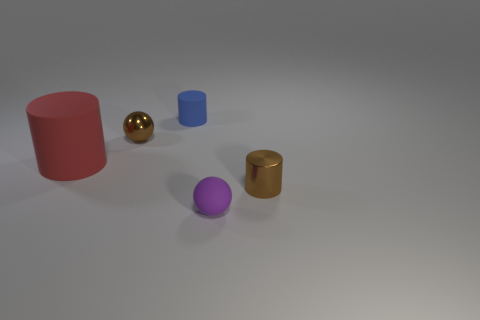What might be the purpose of this arrangement? This arrangement might be for a visualization, study of lighting and shadow, or a demonstration of 3D modeling, showcasing different shapes and materials under uniform lighting. Can you guess what time of day it may represent based on the lighting? It's difficult to ascertain time of day since it's a controlled environment with artificial lighting that does not correlate with natural light. It suggests an indoor setting without natural light influence. 